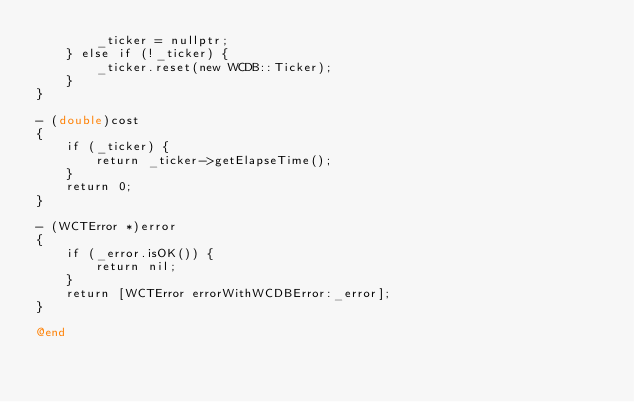<code> <loc_0><loc_0><loc_500><loc_500><_ObjectiveC_>        _ticker = nullptr;
    } else if (!_ticker) {
        _ticker.reset(new WCDB::Ticker);
    }
}

- (double)cost
{
    if (_ticker) {
        return _ticker->getElapseTime();
    }
    return 0;
}

- (WCTError *)error
{
    if (_error.isOK()) {
        return nil;
    }
    return [WCTError errorWithWCDBError:_error];
}

@end
</code> 